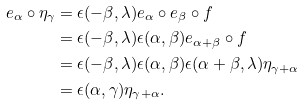Convert formula to latex. <formula><loc_0><loc_0><loc_500><loc_500>e _ { \alpha } \circ \eta _ { \gamma } & = \epsilon ( - \beta , \lambda ) e _ { \alpha } \circ e _ { \beta } \circ f \\ & = \epsilon ( - \beta , \lambda ) \epsilon ( \alpha , \beta ) e _ { \alpha + \beta } \circ f \\ & = \epsilon ( - \beta , \lambda ) \epsilon ( \alpha , \beta ) \epsilon ( \alpha + \beta , \lambda ) \eta _ { \gamma + \alpha } \\ & = \epsilon ( \alpha , \gamma ) \eta _ { \gamma + \alpha } .</formula> 